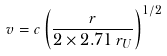<formula> <loc_0><loc_0><loc_500><loc_500>v = c \left ( { \frac { r } { 2 \times 2 . 7 1 \, r _ { U } } } \right ) ^ { 1 / 2 }</formula> 